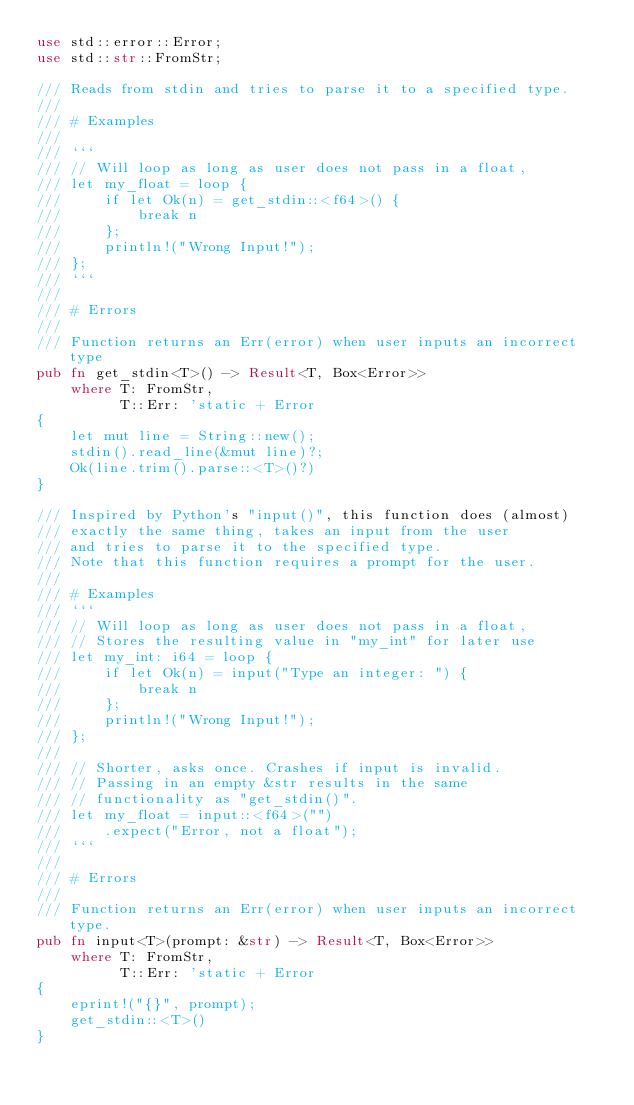Convert code to text. <code><loc_0><loc_0><loc_500><loc_500><_Rust_>use std::error::Error;
use std::str::FromStr;

/// Reads from stdin and tries to parse it to a specified type.
///
/// # Examples
///
/// ```
/// // Will loop as long as user does not pass in a float,
/// let my_float = loop {
///     if let Ok(n) = get_stdin::<f64>() {
///         break n
///     };
///     println!("Wrong Input!");
/// };
/// ```
///
/// # Errors
///
/// Function returns an Err(error) when user inputs an incorrect type
pub fn get_stdin<T>() -> Result<T, Box<Error>> 
    where T: FromStr,
          T::Err: 'static + Error 
{
    let mut line = String::new();
    stdin().read_line(&mut line)?;
    Ok(line.trim().parse::<T>()?)
}

/// Inspired by Python's "input()", this function does (almost)
/// exactly the same thing, takes an input from the user
/// and tries to parse it to the specified type.
/// Note that this function requires a prompt for the user.
///
/// # Examples
/// ```
/// // Will loop as long as user does not pass in a float,
/// // Stores the resulting value in "my_int" for later use
/// let my_int: i64 = loop {
///     if let Ok(n) = input("Type an integer: ") {
///         break n
///     };
///     println!("Wrong Input!");
/// };
///
/// // Shorter, asks once. Crashes if input is invalid.
/// // Passing in an empty &str results in the same
/// // functionality as "get_stdin()".
/// let my_float = input::<f64>("")
///     .expect("Error, not a float");
/// ```
/// 
/// # Errors
///
/// Function returns an Err(error) when user inputs an incorrect type.
pub fn input<T>(prompt: &str) -> Result<T, Box<Error>> 
    where T: FromStr,
          T::Err: 'static + Error 
{
    eprint!("{}", prompt);
    get_stdin::<T>() 
}
</code> 